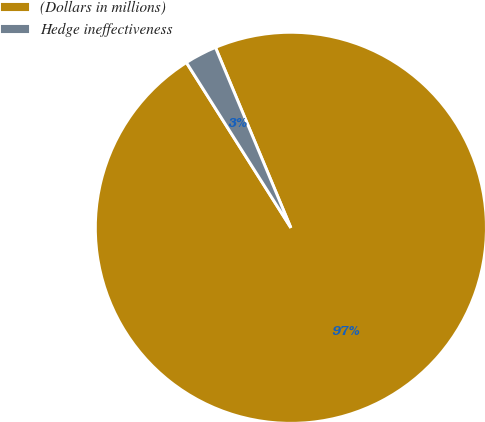<chart> <loc_0><loc_0><loc_500><loc_500><pie_chart><fcel>(Dollars in millions)<fcel>Hedge ineffectiveness<nl><fcel>97.33%<fcel>2.67%<nl></chart> 